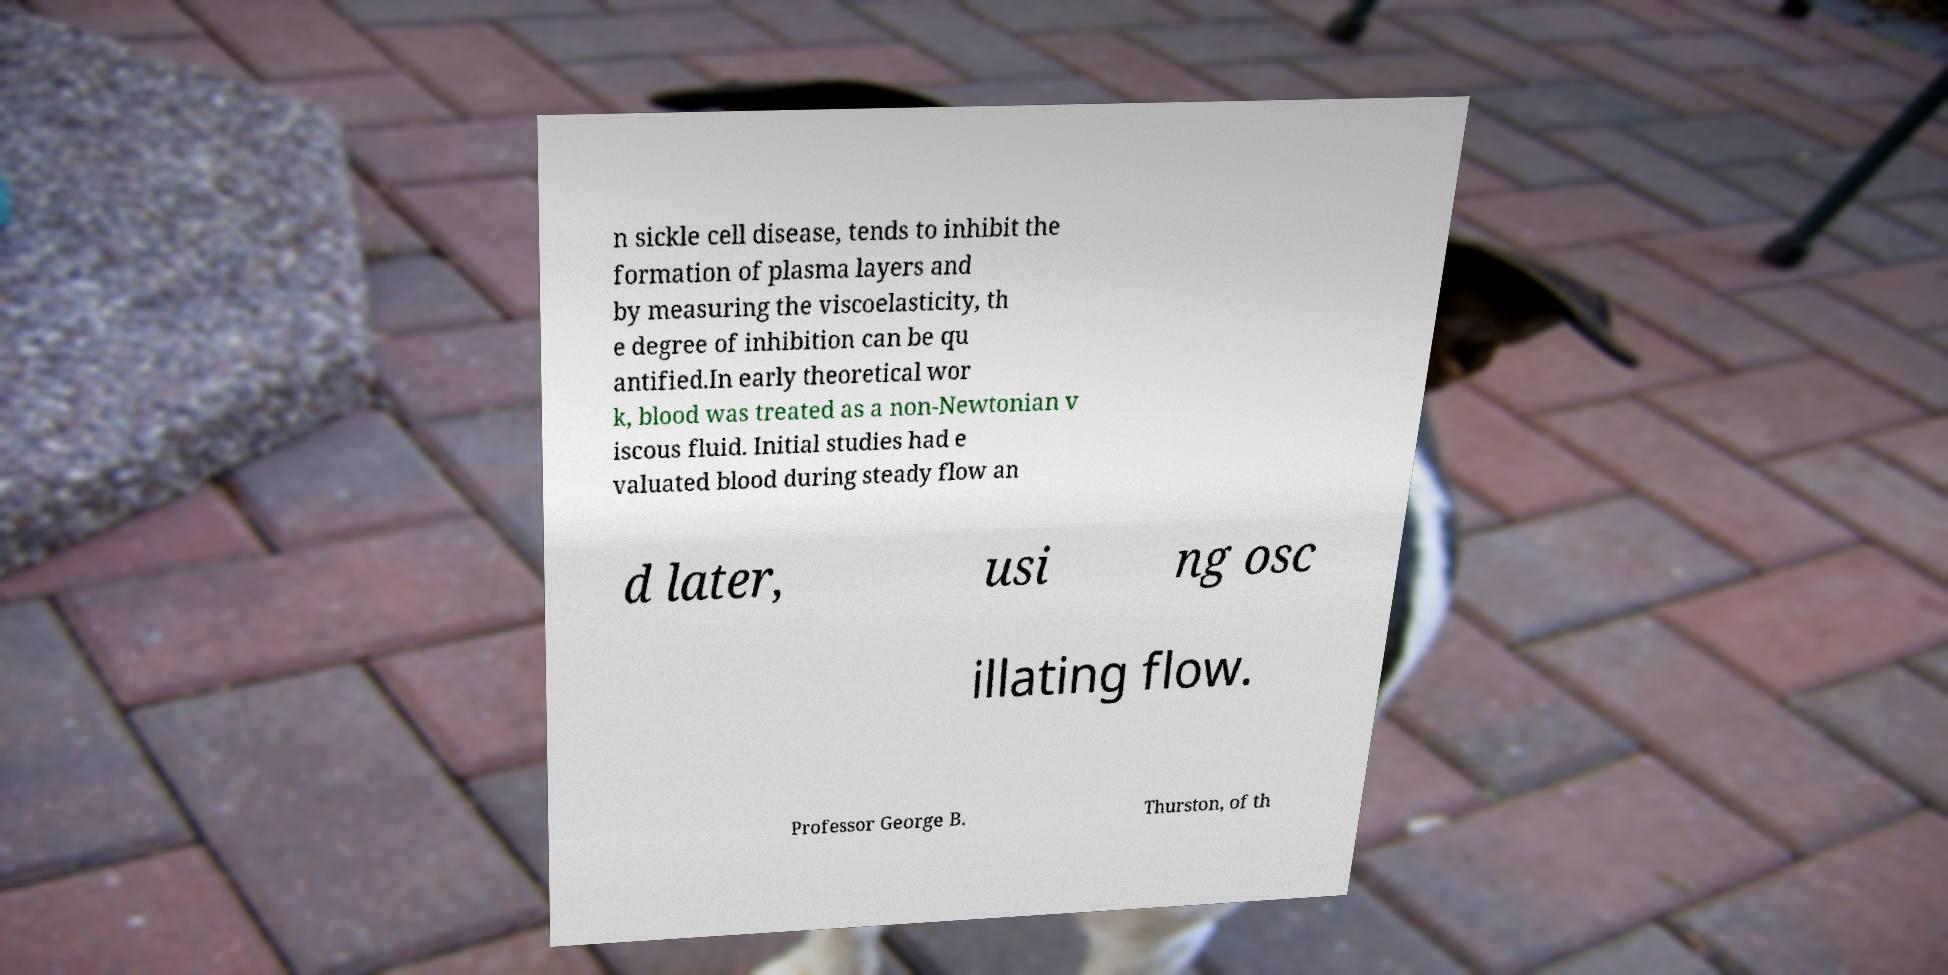Please read and relay the text visible in this image. What does it say? n sickle cell disease, tends to inhibit the formation of plasma layers and by measuring the viscoelasticity, th e degree of inhibition can be qu antified.In early theoretical wor k, blood was treated as a non-Newtonian v iscous fluid. Initial studies had e valuated blood during steady flow an d later, usi ng osc illating flow. Professor George B. Thurston, of th 